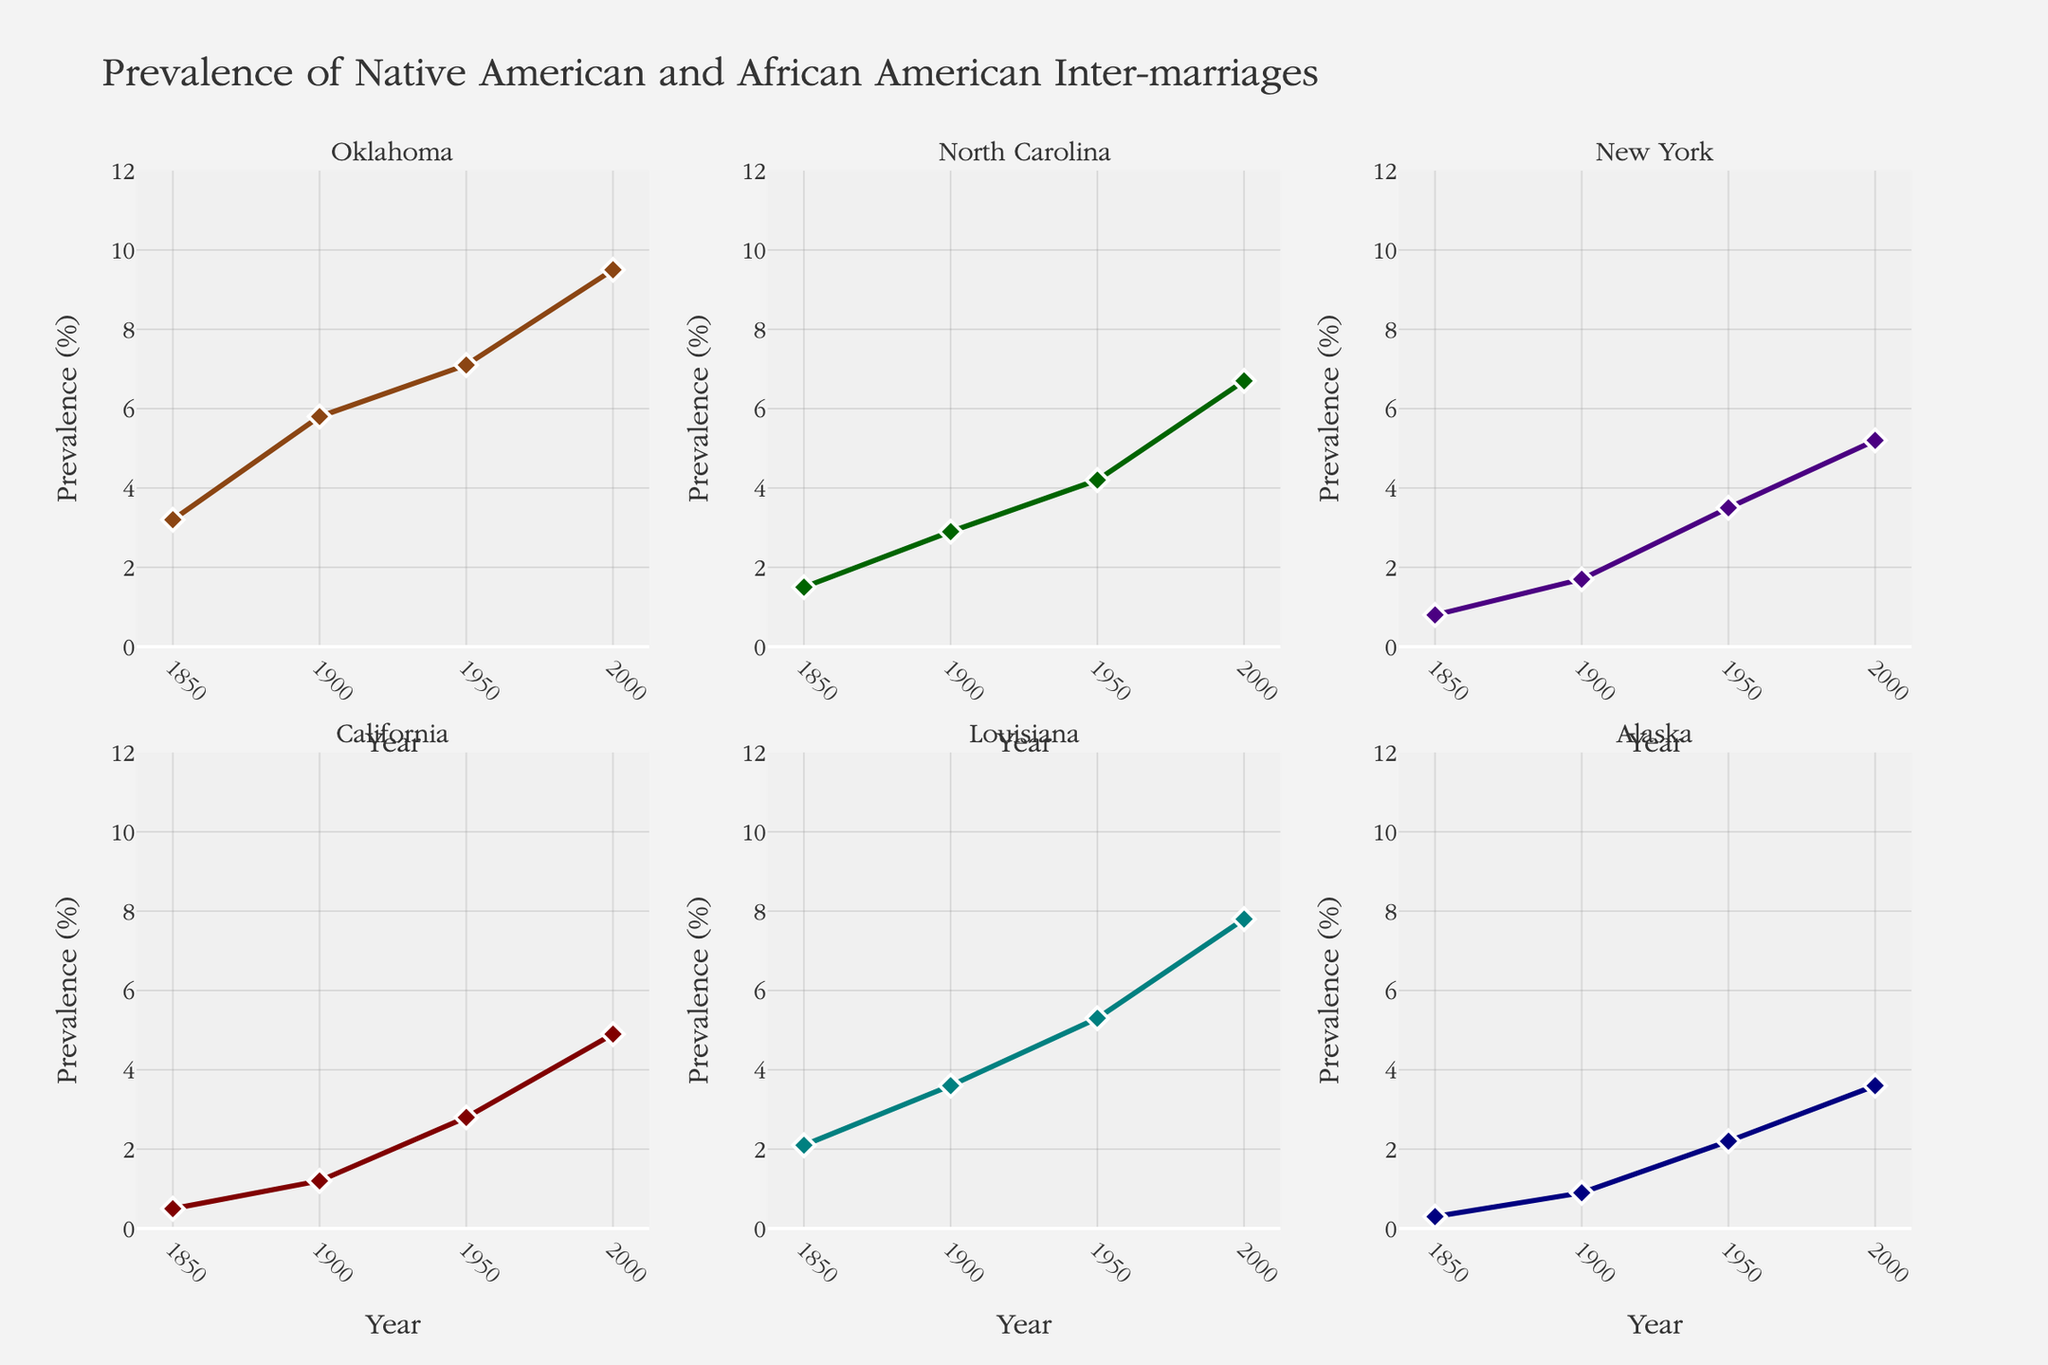What is the title of the chart? The title is displayed at the top of the figure, and it reads "Prevalence of Native American and African American Inter-marriages".
Answer: Prevalence of Native American and African American Inter-marriages Which region showed the highest prevalence of inter-marriages in 2000? By observing the data points for each region in the year 2000, the subplot for Oklahoma has the highest value.
Answer: Oklahoma How did the prevalence of inter-marriages in North Carolina change from 1850 to 2000? From the subplot for North Carolina, we can see the value at 1850 as 1.5% and at 2000 as 6.7%. Subtracting 1.5 from 6.7 gives the change.
Answer: 5.2% Which two regions showed similar prevalences of inter-marriages around the year 1950? By checking the data points around 1950 for each subplot, California (2.8%) and Alaska (2.2%) have the closest values.
Answer: California and Alaska Which region had the slowest growth in inter-marriages between 1850 and 2000? By calculating the difference between the values for 2000 and 1850 in each subplot, Alaska shows the slowest growth (3.6% - 0.3% = 3.3%).
Answer: Alaska Compare the prevalence of inter-marriages in New York and Louisiana in 1900. Which region had a higher prevalence, and by how much? By checking the subplots for New York (1.7%) and Louisiana (3.6%) in 1900, Louisiana had a higher prevalence. The difference is 3.6 - 1.7 = 1.9%.
Answer: Louisiana by 1.9% What is the overall trend in inter-marriages for all regions from 1850 to 2000? Observing all subplots, all regions show an increasing trend in the prevalence of inter-marriages from 1850 to 2000.
Answer: Increasing Which region's prevalence of inter-marriages saw the largest percentage increase from 1900 to 1950? By calculating the percentage increase for each region from 1900 to 1950, Oklahoma increased from 5.8% to 7.1%, which is the largest percentage change.
Answer: Oklahoma Which region showed the second-highest prevalence of inter-marriages in 1950? Observing the data points in 1950, Louisiana with 5.3% is the second-highest after Oklahoma.
Answer: Louisiana 